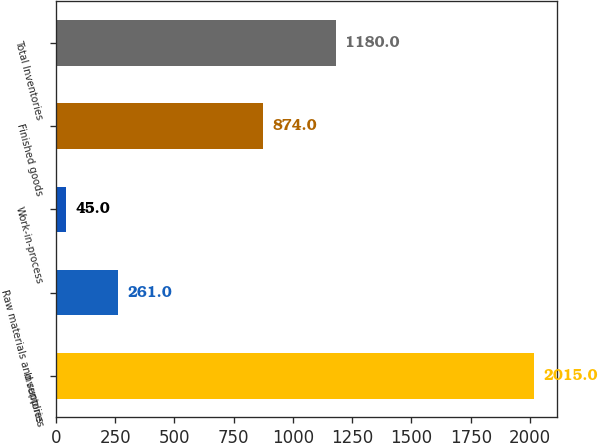Convert chart. <chart><loc_0><loc_0><loc_500><loc_500><bar_chart><fcel>Inventories<fcel>Raw materials and supplies<fcel>Work-in-process<fcel>Finished goods<fcel>Total Inventories<nl><fcel>2015<fcel>261<fcel>45<fcel>874<fcel>1180<nl></chart> 